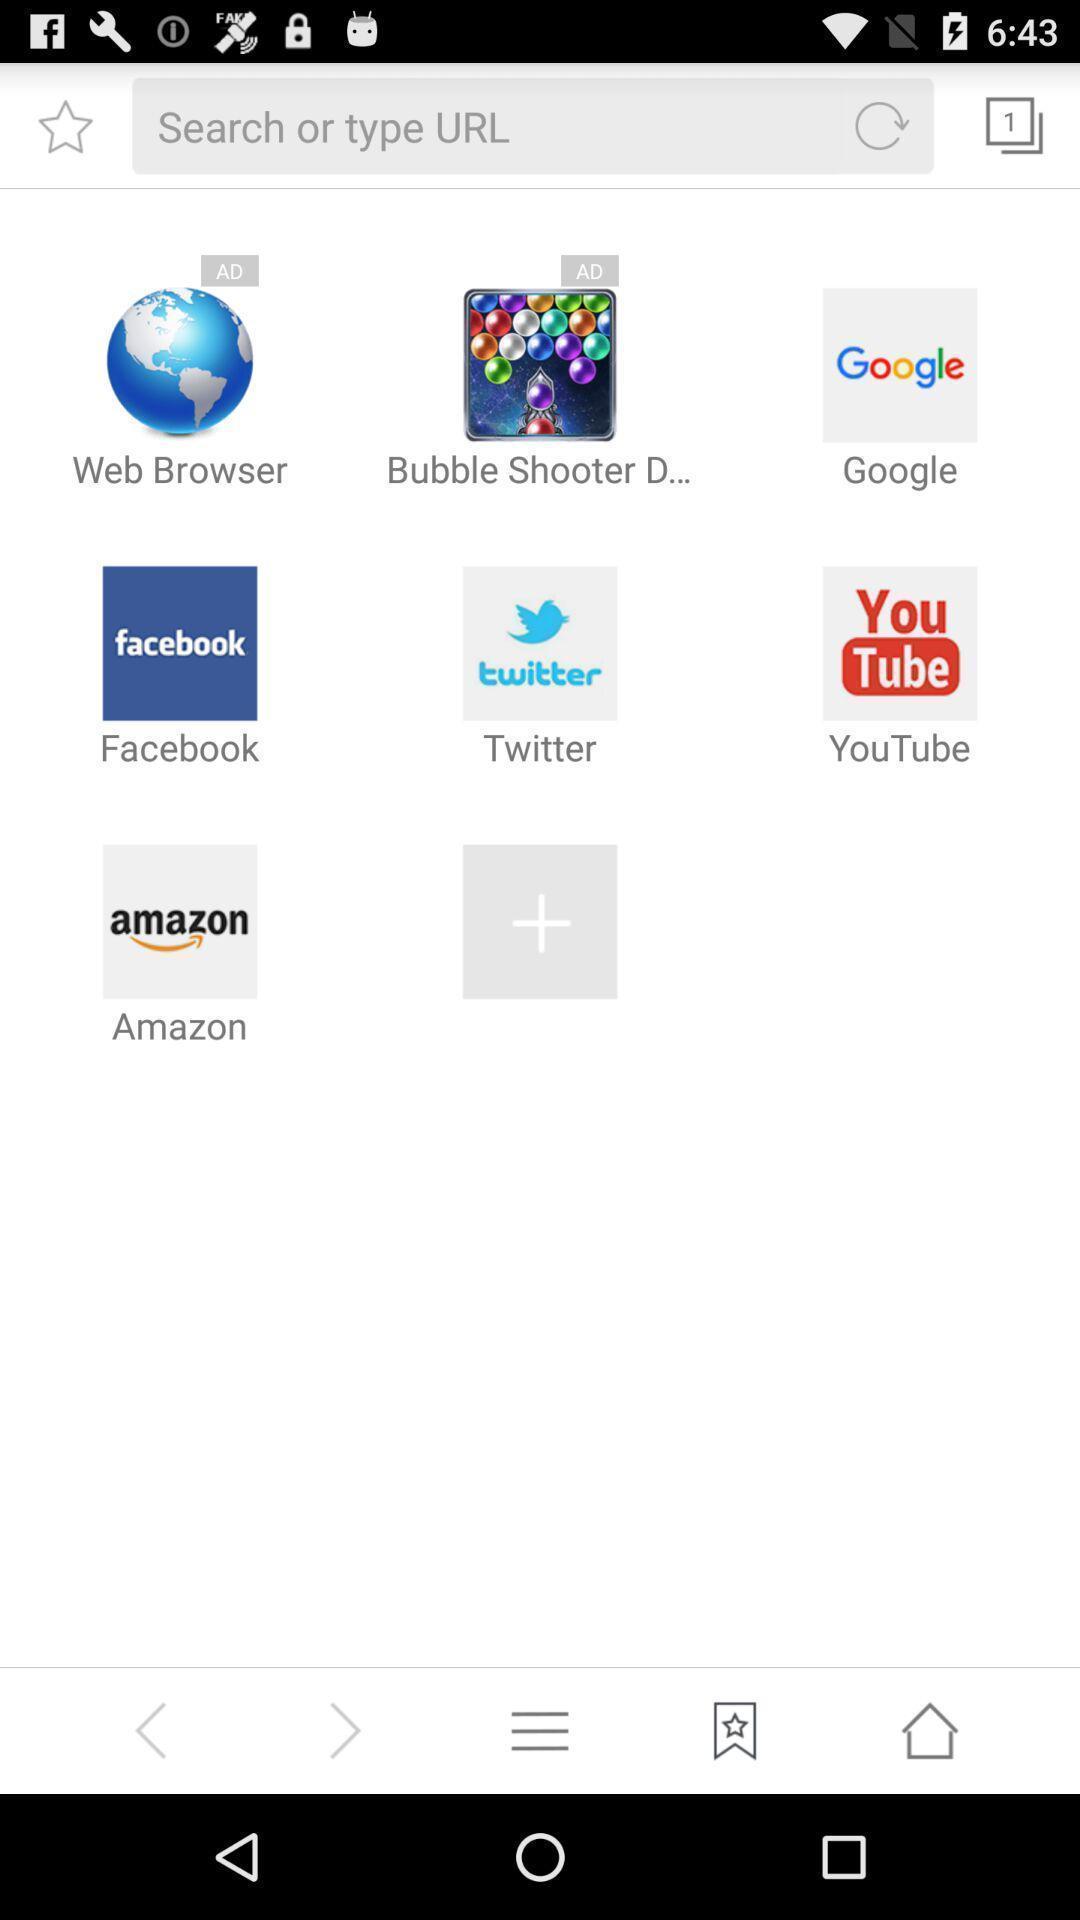Give me a narrative description of this picture. Page displaying with list of application options. 